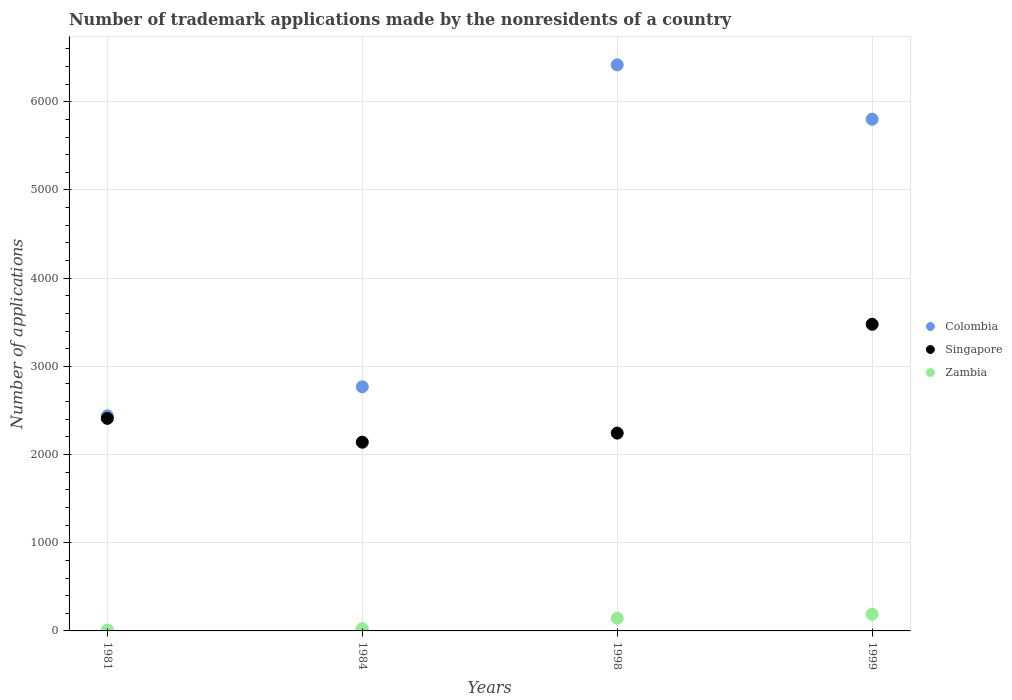How many different coloured dotlines are there?
Provide a short and direct response. 3. Is the number of dotlines equal to the number of legend labels?
Keep it short and to the point. Yes. What is the number of trademark applications made by the nonresidents in Colombia in 1981?
Provide a succinct answer. 2439. Across all years, what is the maximum number of trademark applications made by the nonresidents in Zambia?
Your response must be concise. 189. Across all years, what is the minimum number of trademark applications made by the nonresidents in Colombia?
Provide a short and direct response. 2439. In which year was the number of trademark applications made by the nonresidents in Zambia minimum?
Provide a short and direct response. 1981. What is the total number of trademark applications made by the nonresidents in Singapore in the graph?
Your answer should be very brief. 1.03e+04. What is the difference between the number of trademark applications made by the nonresidents in Zambia in 1998 and that in 1999?
Ensure brevity in your answer.  -45. What is the difference between the number of trademark applications made by the nonresidents in Colombia in 1981 and the number of trademark applications made by the nonresidents in Zambia in 1999?
Make the answer very short. 2250. What is the average number of trademark applications made by the nonresidents in Colombia per year?
Ensure brevity in your answer.  4357. In the year 1981, what is the difference between the number of trademark applications made by the nonresidents in Colombia and number of trademark applications made by the nonresidents in Zambia?
Make the answer very short. 2428. What is the ratio of the number of trademark applications made by the nonresidents in Zambia in 1981 to that in 1984?
Provide a succinct answer. 0.44. What is the difference between the highest and the lowest number of trademark applications made by the nonresidents in Colombia?
Your answer should be compact. 3980. In how many years, is the number of trademark applications made by the nonresidents in Colombia greater than the average number of trademark applications made by the nonresidents in Colombia taken over all years?
Ensure brevity in your answer.  2. Is the sum of the number of trademark applications made by the nonresidents in Singapore in 1984 and 1999 greater than the maximum number of trademark applications made by the nonresidents in Zambia across all years?
Offer a terse response. Yes. Is it the case that in every year, the sum of the number of trademark applications made by the nonresidents in Zambia and number of trademark applications made by the nonresidents in Singapore  is greater than the number of trademark applications made by the nonresidents in Colombia?
Your answer should be very brief. No. Does the number of trademark applications made by the nonresidents in Zambia monotonically increase over the years?
Offer a very short reply. Yes. Is the number of trademark applications made by the nonresidents in Singapore strictly greater than the number of trademark applications made by the nonresidents in Colombia over the years?
Keep it short and to the point. No. How many dotlines are there?
Make the answer very short. 3. What is the difference between two consecutive major ticks on the Y-axis?
Your response must be concise. 1000. Are the values on the major ticks of Y-axis written in scientific E-notation?
Keep it short and to the point. No. Does the graph contain any zero values?
Offer a terse response. No. Does the graph contain grids?
Ensure brevity in your answer.  Yes. What is the title of the graph?
Provide a succinct answer. Number of trademark applications made by the nonresidents of a country. What is the label or title of the X-axis?
Your answer should be very brief. Years. What is the label or title of the Y-axis?
Ensure brevity in your answer.  Number of applications. What is the Number of applications in Colombia in 1981?
Make the answer very short. 2439. What is the Number of applications in Singapore in 1981?
Give a very brief answer. 2410. What is the Number of applications of Zambia in 1981?
Your answer should be very brief. 11. What is the Number of applications of Colombia in 1984?
Keep it short and to the point. 2768. What is the Number of applications in Singapore in 1984?
Give a very brief answer. 2140. What is the Number of applications in Zambia in 1984?
Give a very brief answer. 25. What is the Number of applications in Colombia in 1998?
Give a very brief answer. 6419. What is the Number of applications of Singapore in 1998?
Give a very brief answer. 2243. What is the Number of applications of Zambia in 1998?
Your answer should be very brief. 144. What is the Number of applications of Colombia in 1999?
Ensure brevity in your answer.  5802. What is the Number of applications in Singapore in 1999?
Keep it short and to the point. 3477. What is the Number of applications of Zambia in 1999?
Provide a succinct answer. 189. Across all years, what is the maximum Number of applications of Colombia?
Provide a succinct answer. 6419. Across all years, what is the maximum Number of applications of Singapore?
Ensure brevity in your answer.  3477. Across all years, what is the maximum Number of applications of Zambia?
Keep it short and to the point. 189. Across all years, what is the minimum Number of applications of Colombia?
Ensure brevity in your answer.  2439. Across all years, what is the minimum Number of applications in Singapore?
Ensure brevity in your answer.  2140. Across all years, what is the minimum Number of applications in Zambia?
Your answer should be very brief. 11. What is the total Number of applications of Colombia in the graph?
Your response must be concise. 1.74e+04. What is the total Number of applications in Singapore in the graph?
Make the answer very short. 1.03e+04. What is the total Number of applications in Zambia in the graph?
Offer a terse response. 369. What is the difference between the Number of applications in Colombia in 1981 and that in 1984?
Keep it short and to the point. -329. What is the difference between the Number of applications of Singapore in 1981 and that in 1984?
Make the answer very short. 270. What is the difference between the Number of applications of Colombia in 1981 and that in 1998?
Your answer should be very brief. -3980. What is the difference between the Number of applications of Singapore in 1981 and that in 1998?
Give a very brief answer. 167. What is the difference between the Number of applications in Zambia in 1981 and that in 1998?
Your answer should be compact. -133. What is the difference between the Number of applications in Colombia in 1981 and that in 1999?
Provide a succinct answer. -3363. What is the difference between the Number of applications of Singapore in 1981 and that in 1999?
Your answer should be very brief. -1067. What is the difference between the Number of applications in Zambia in 1981 and that in 1999?
Provide a short and direct response. -178. What is the difference between the Number of applications in Colombia in 1984 and that in 1998?
Keep it short and to the point. -3651. What is the difference between the Number of applications in Singapore in 1984 and that in 1998?
Give a very brief answer. -103. What is the difference between the Number of applications in Zambia in 1984 and that in 1998?
Offer a terse response. -119. What is the difference between the Number of applications in Colombia in 1984 and that in 1999?
Your answer should be compact. -3034. What is the difference between the Number of applications in Singapore in 1984 and that in 1999?
Your answer should be very brief. -1337. What is the difference between the Number of applications in Zambia in 1984 and that in 1999?
Provide a succinct answer. -164. What is the difference between the Number of applications of Colombia in 1998 and that in 1999?
Your answer should be compact. 617. What is the difference between the Number of applications of Singapore in 1998 and that in 1999?
Offer a very short reply. -1234. What is the difference between the Number of applications in Zambia in 1998 and that in 1999?
Offer a very short reply. -45. What is the difference between the Number of applications in Colombia in 1981 and the Number of applications in Singapore in 1984?
Offer a terse response. 299. What is the difference between the Number of applications in Colombia in 1981 and the Number of applications in Zambia in 1984?
Provide a short and direct response. 2414. What is the difference between the Number of applications in Singapore in 1981 and the Number of applications in Zambia in 1984?
Make the answer very short. 2385. What is the difference between the Number of applications of Colombia in 1981 and the Number of applications of Singapore in 1998?
Keep it short and to the point. 196. What is the difference between the Number of applications of Colombia in 1981 and the Number of applications of Zambia in 1998?
Your answer should be very brief. 2295. What is the difference between the Number of applications of Singapore in 1981 and the Number of applications of Zambia in 1998?
Your response must be concise. 2266. What is the difference between the Number of applications in Colombia in 1981 and the Number of applications in Singapore in 1999?
Make the answer very short. -1038. What is the difference between the Number of applications in Colombia in 1981 and the Number of applications in Zambia in 1999?
Give a very brief answer. 2250. What is the difference between the Number of applications in Singapore in 1981 and the Number of applications in Zambia in 1999?
Provide a short and direct response. 2221. What is the difference between the Number of applications of Colombia in 1984 and the Number of applications of Singapore in 1998?
Provide a succinct answer. 525. What is the difference between the Number of applications in Colombia in 1984 and the Number of applications in Zambia in 1998?
Your answer should be compact. 2624. What is the difference between the Number of applications in Singapore in 1984 and the Number of applications in Zambia in 1998?
Provide a short and direct response. 1996. What is the difference between the Number of applications of Colombia in 1984 and the Number of applications of Singapore in 1999?
Offer a terse response. -709. What is the difference between the Number of applications of Colombia in 1984 and the Number of applications of Zambia in 1999?
Make the answer very short. 2579. What is the difference between the Number of applications of Singapore in 1984 and the Number of applications of Zambia in 1999?
Your answer should be very brief. 1951. What is the difference between the Number of applications in Colombia in 1998 and the Number of applications in Singapore in 1999?
Make the answer very short. 2942. What is the difference between the Number of applications in Colombia in 1998 and the Number of applications in Zambia in 1999?
Give a very brief answer. 6230. What is the difference between the Number of applications of Singapore in 1998 and the Number of applications of Zambia in 1999?
Give a very brief answer. 2054. What is the average Number of applications in Colombia per year?
Offer a very short reply. 4357. What is the average Number of applications of Singapore per year?
Provide a succinct answer. 2567.5. What is the average Number of applications of Zambia per year?
Provide a short and direct response. 92.25. In the year 1981, what is the difference between the Number of applications in Colombia and Number of applications in Singapore?
Make the answer very short. 29. In the year 1981, what is the difference between the Number of applications in Colombia and Number of applications in Zambia?
Your answer should be compact. 2428. In the year 1981, what is the difference between the Number of applications in Singapore and Number of applications in Zambia?
Offer a very short reply. 2399. In the year 1984, what is the difference between the Number of applications of Colombia and Number of applications of Singapore?
Ensure brevity in your answer.  628. In the year 1984, what is the difference between the Number of applications of Colombia and Number of applications of Zambia?
Keep it short and to the point. 2743. In the year 1984, what is the difference between the Number of applications in Singapore and Number of applications in Zambia?
Provide a short and direct response. 2115. In the year 1998, what is the difference between the Number of applications in Colombia and Number of applications in Singapore?
Provide a short and direct response. 4176. In the year 1998, what is the difference between the Number of applications in Colombia and Number of applications in Zambia?
Give a very brief answer. 6275. In the year 1998, what is the difference between the Number of applications in Singapore and Number of applications in Zambia?
Offer a very short reply. 2099. In the year 1999, what is the difference between the Number of applications in Colombia and Number of applications in Singapore?
Keep it short and to the point. 2325. In the year 1999, what is the difference between the Number of applications in Colombia and Number of applications in Zambia?
Offer a terse response. 5613. In the year 1999, what is the difference between the Number of applications in Singapore and Number of applications in Zambia?
Ensure brevity in your answer.  3288. What is the ratio of the Number of applications of Colombia in 1981 to that in 1984?
Offer a very short reply. 0.88. What is the ratio of the Number of applications of Singapore in 1981 to that in 1984?
Offer a very short reply. 1.13. What is the ratio of the Number of applications in Zambia in 1981 to that in 1984?
Ensure brevity in your answer.  0.44. What is the ratio of the Number of applications of Colombia in 1981 to that in 1998?
Offer a terse response. 0.38. What is the ratio of the Number of applications in Singapore in 1981 to that in 1998?
Give a very brief answer. 1.07. What is the ratio of the Number of applications of Zambia in 1981 to that in 1998?
Provide a short and direct response. 0.08. What is the ratio of the Number of applications in Colombia in 1981 to that in 1999?
Your response must be concise. 0.42. What is the ratio of the Number of applications of Singapore in 1981 to that in 1999?
Give a very brief answer. 0.69. What is the ratio of the Number of applications in Zambia in 1981 to that in 1999?
Your answer should be compact. 0.06. What is the ratio of the Number of applications in Colombia in 1984 to that in 1998?
Give a very brief answer. 0.43. What is the ratio of the Number of applications in Singapore in 1984 to that in 1998?
Provide a succinct answer. 0.95. What is the ratio of the Number of applications in Zambia in 1984 to that in 1998?
Your response must be concise. 0.17. What is the ratio of the Number of applications in Colombia in 1984 to that in 1999?
Your response must be concise. 0.48. What is the ratio of the Number of applications in Singapore in 1984 to that in 1999?
Make the answer very short. 0.62. What is the ratio of the Number of applications of Zambia in 1984 to that in 1999?
Offer a very short reply. 0.13. What is the ratio of the Number of applications of Colombia in 1998 to that in 1999?
Ensure brevity in your answer.  1.11. What is the ratio of the Number of applications of Singapore in 1998 to that in 1999?
Your answer should be very brief. 0.65. What is the ratio of the Number of applications of Zambia in 1998 to that in 1999?
Make the answer very short. 0.76. What is the difference between the highest and the second highest Number of applications of Colombia?
Offer a terse response. 617. What is the difference between the highest and the second highest Number of applications in Singapore?
Offer a terse response. 1067. What is the difference between the highest and the lowest Number of applications of Colombia?
Your response must be concise. 3980. What is the difference between the highest and the lowest Number of applications of Singapore?
Your answer should be compact. 1337. What is the difference between the highest and the lowest Number of applications in Zambia?
Give a very brief answer. 178. 